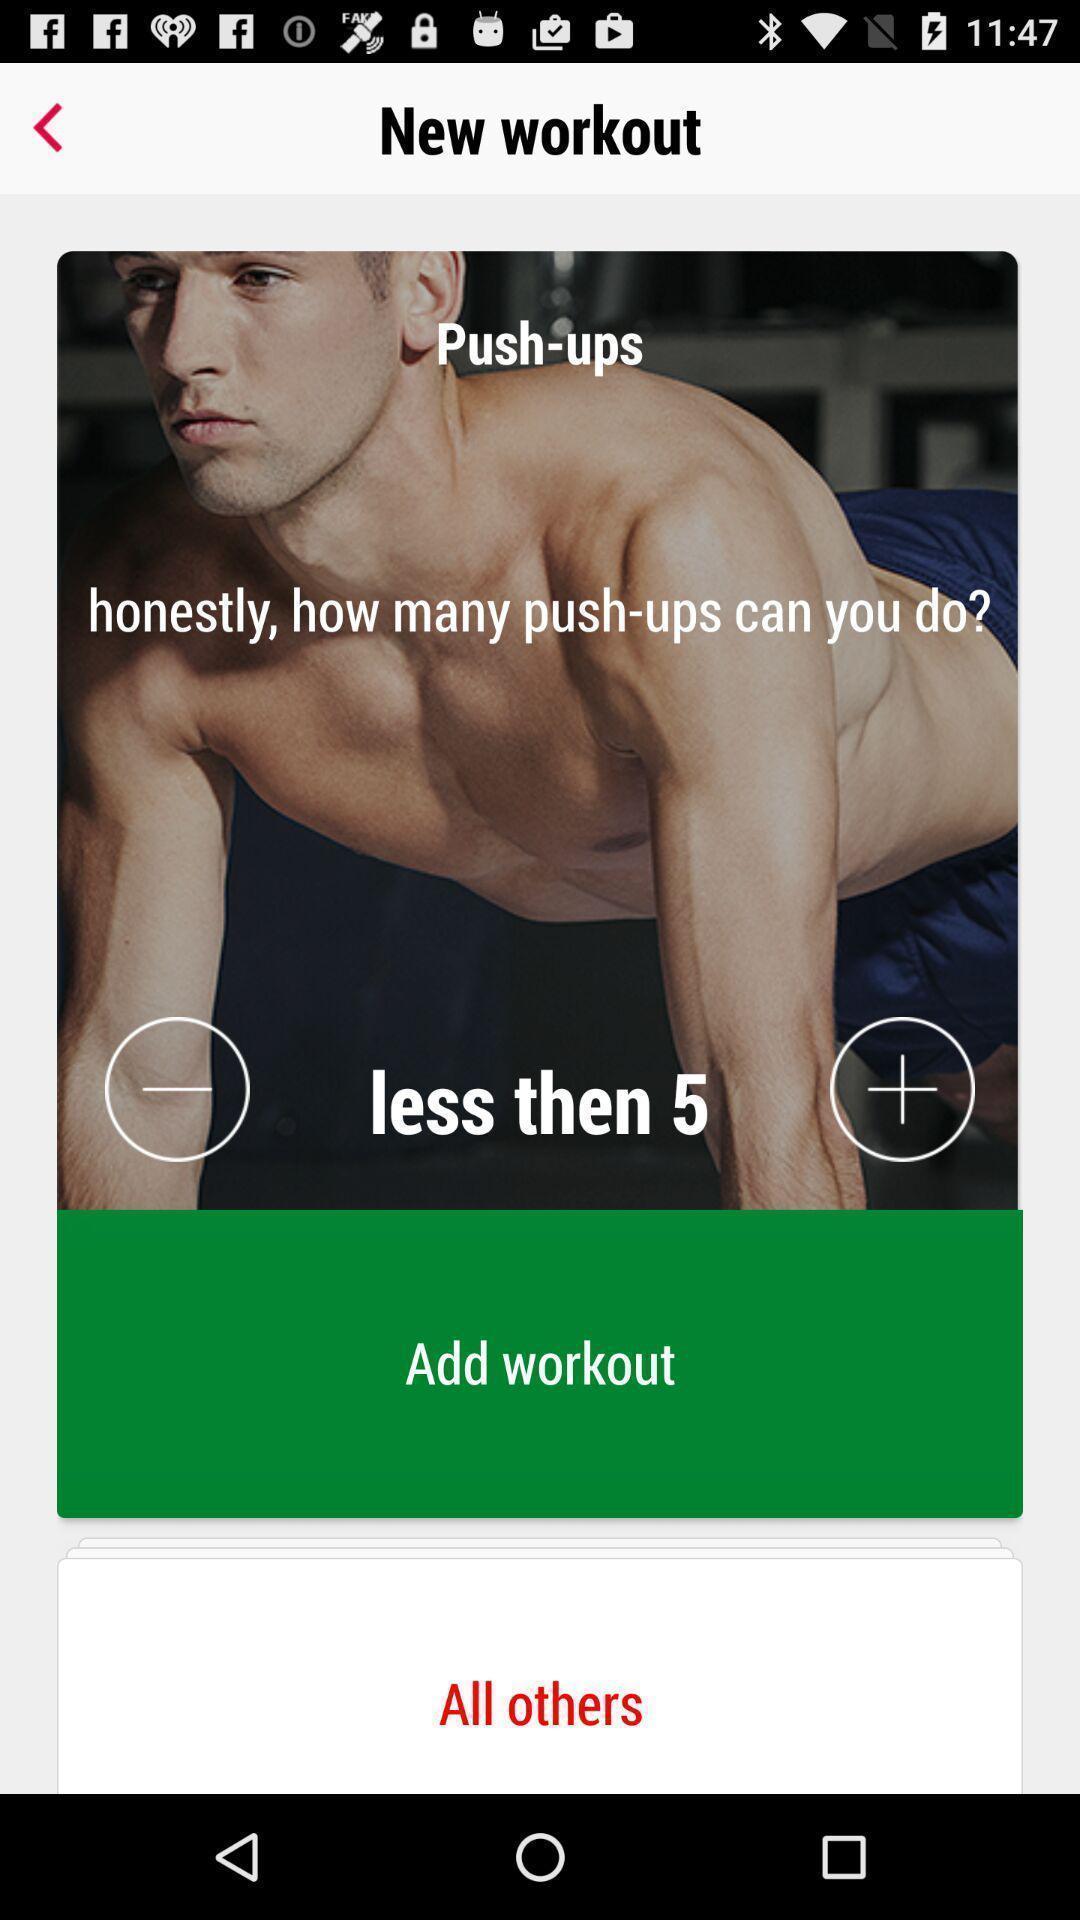Tell me about the visual elements in this screen capture. Page shows to add your workout list in fitness app. 